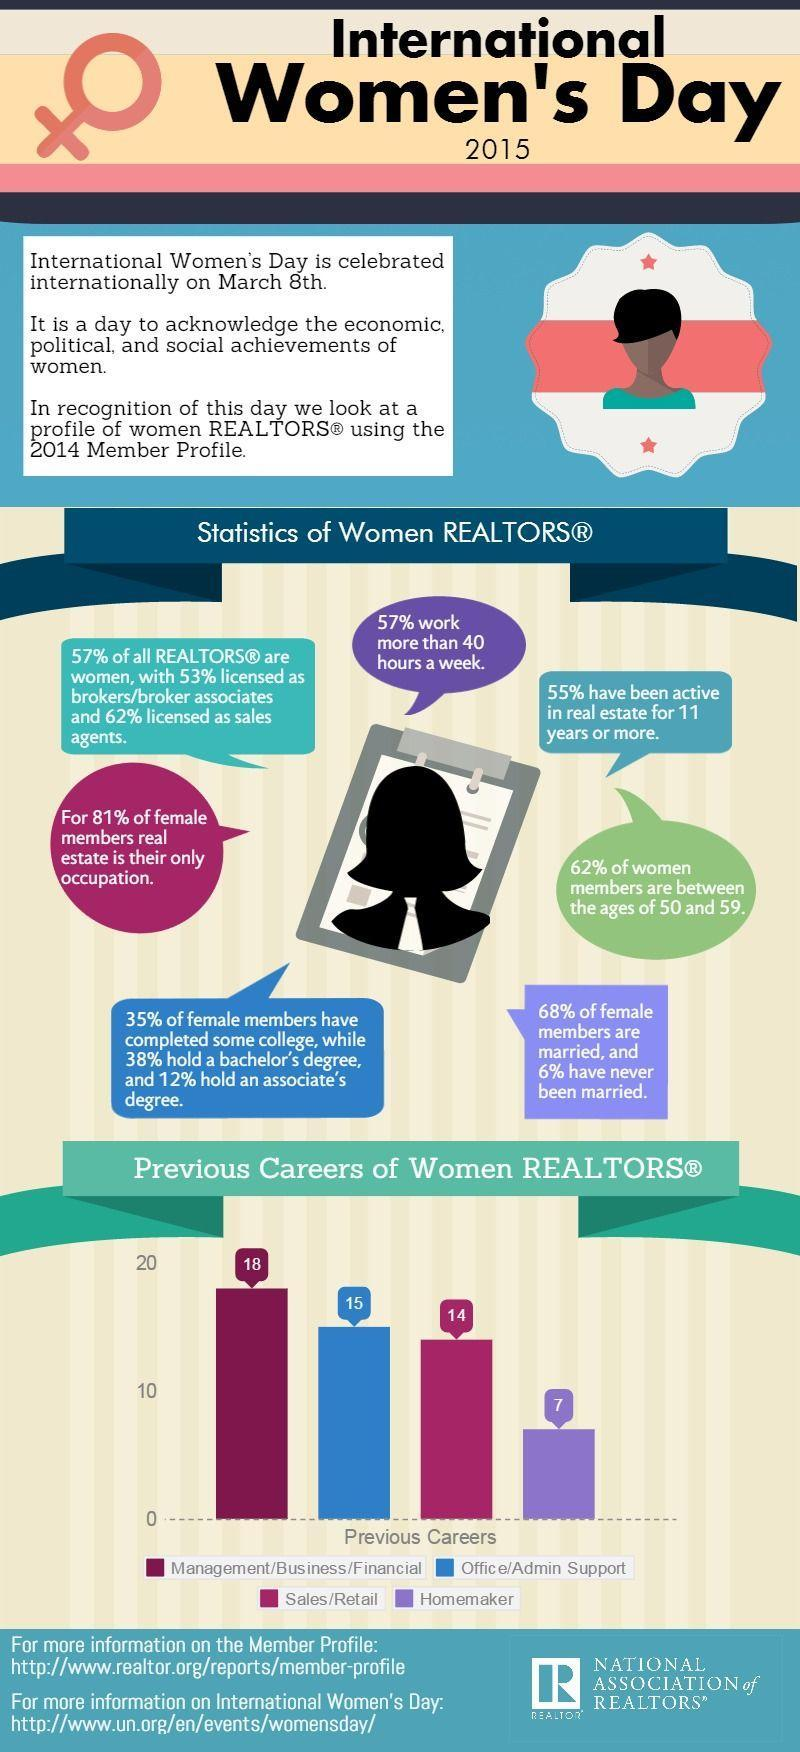According to the graph, how many women were working in Office/Admin support?
Answer the question with a short phrase. 15 Which career did majority of female realtors have previously? Management/Business/Financial 